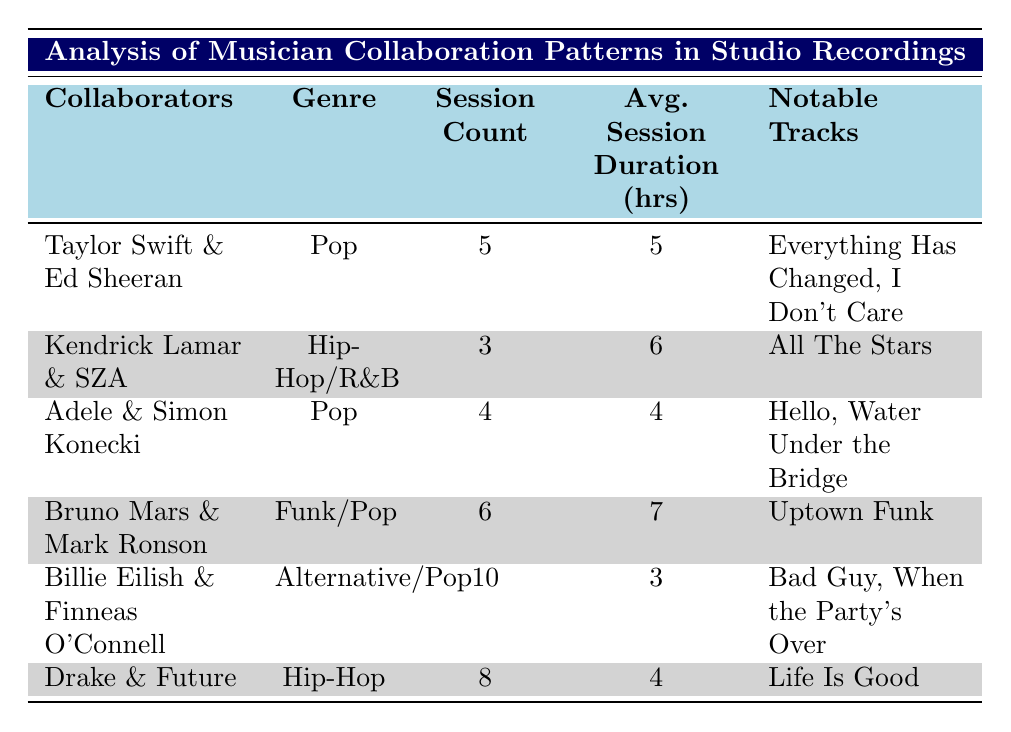What is the average session duration for the collaboration between Billie Eilish and Finneas O'Connell? The table lists the average session duration for Billie Eilish and Finneas O'Connell as 3 hours.
Answer: 3 hours Which collaboration has the highest session count? The table indicates that Billie Eilish and Finneas O'Connell have the highest session count with 10 sessions.
Answer: Billie Eilish and Finneas O'Connell Is the genre for the collaboration between Drake and Future classified as Hip-Hop? The genre for Drake and Future is listed as Hip-Hop, so the statement is true.
Answer: Yes What is the total session count for the collaborations in the Pop genre? The Pop collaborations are Taylor Swift & Ed Sheeran with 5 sessions and Adele & Simon Konecki with 4 sessions. So, the total is 5 + 4 = 9 sessions.
Answer: 9 sessions Which collaborators worked together for the longest average session duration? The table shows that Bruno Mars and Mark Ronson worked for an average session duration of 7 hours, which is the longest among all collaborations.
Answer: Bruno Mars and Mark Ronson How many notable tracks did Adele and Simon Konecki produce? According to the table, Adele and Simon Konecki produced 2 notable tracks: "Hello" and "Water Under the Bridge."
Answer: 2 notable tracks Is there a collaboration involving two musicians from the Hip-Hop/R&B genre that had more than 5 sessions? Reviewing the table, there are no collaborations in the Hip-Hop/R&B genre with more than 5 sessions since Kendrick Lamar and SZA have 3 sessions.
Answer: No What is the average session duration for the Funk/Pop collaborations compared to those in the Alternative/Pop genre? The average session duration for Funk/Pop (Bruno Mars and Mark Ronson) is 7 hours, while for Alternative/Pop (Billie Eilish and Finneas O'Connell), it is 3 hours. Thus, Funk/Pop has a longer average session duration.
Answer: Funk/Pop has a longer duration 